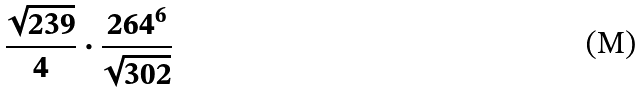Convert formula to latex. <formula><loc_0><loc_0><loc_500><loc_500>\frac { \sqrt { 2 3 9 } } { 4 } \cdot \frac { 2 6 4 ^ { 6 } } { \sqrt { 3 0 2 } }</formula> 